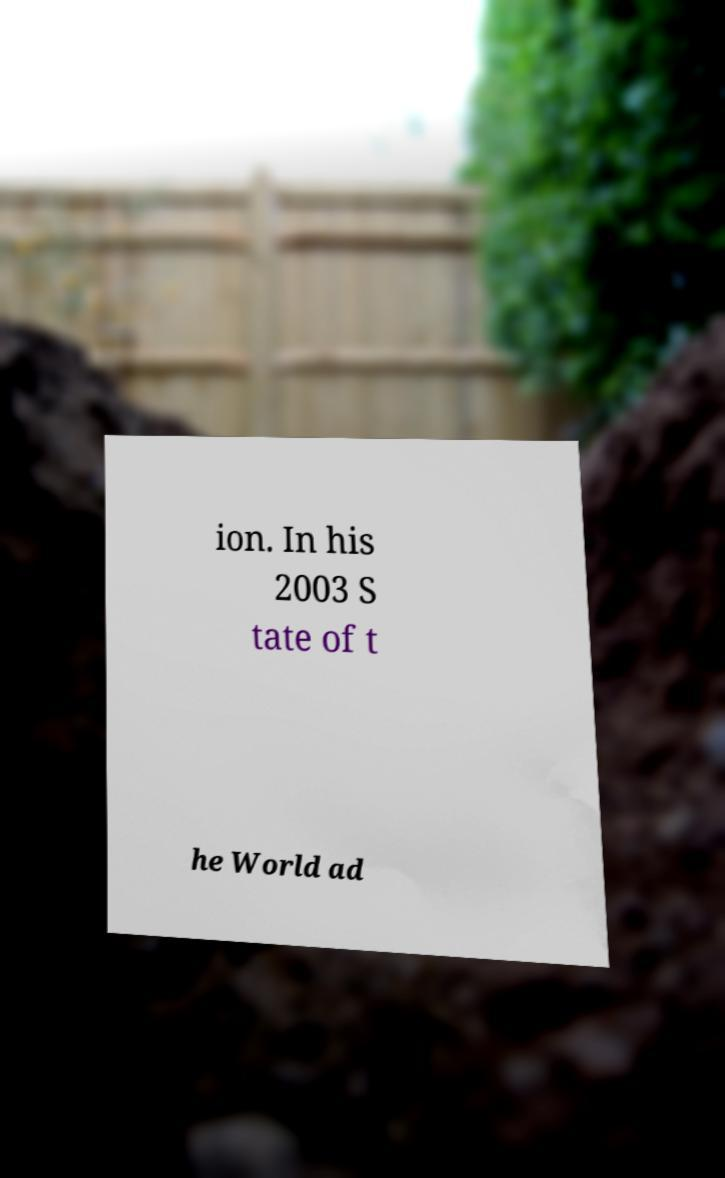Please identify and transcribe the text found in this image. ion. In his 2003 S tate of t he World ad 